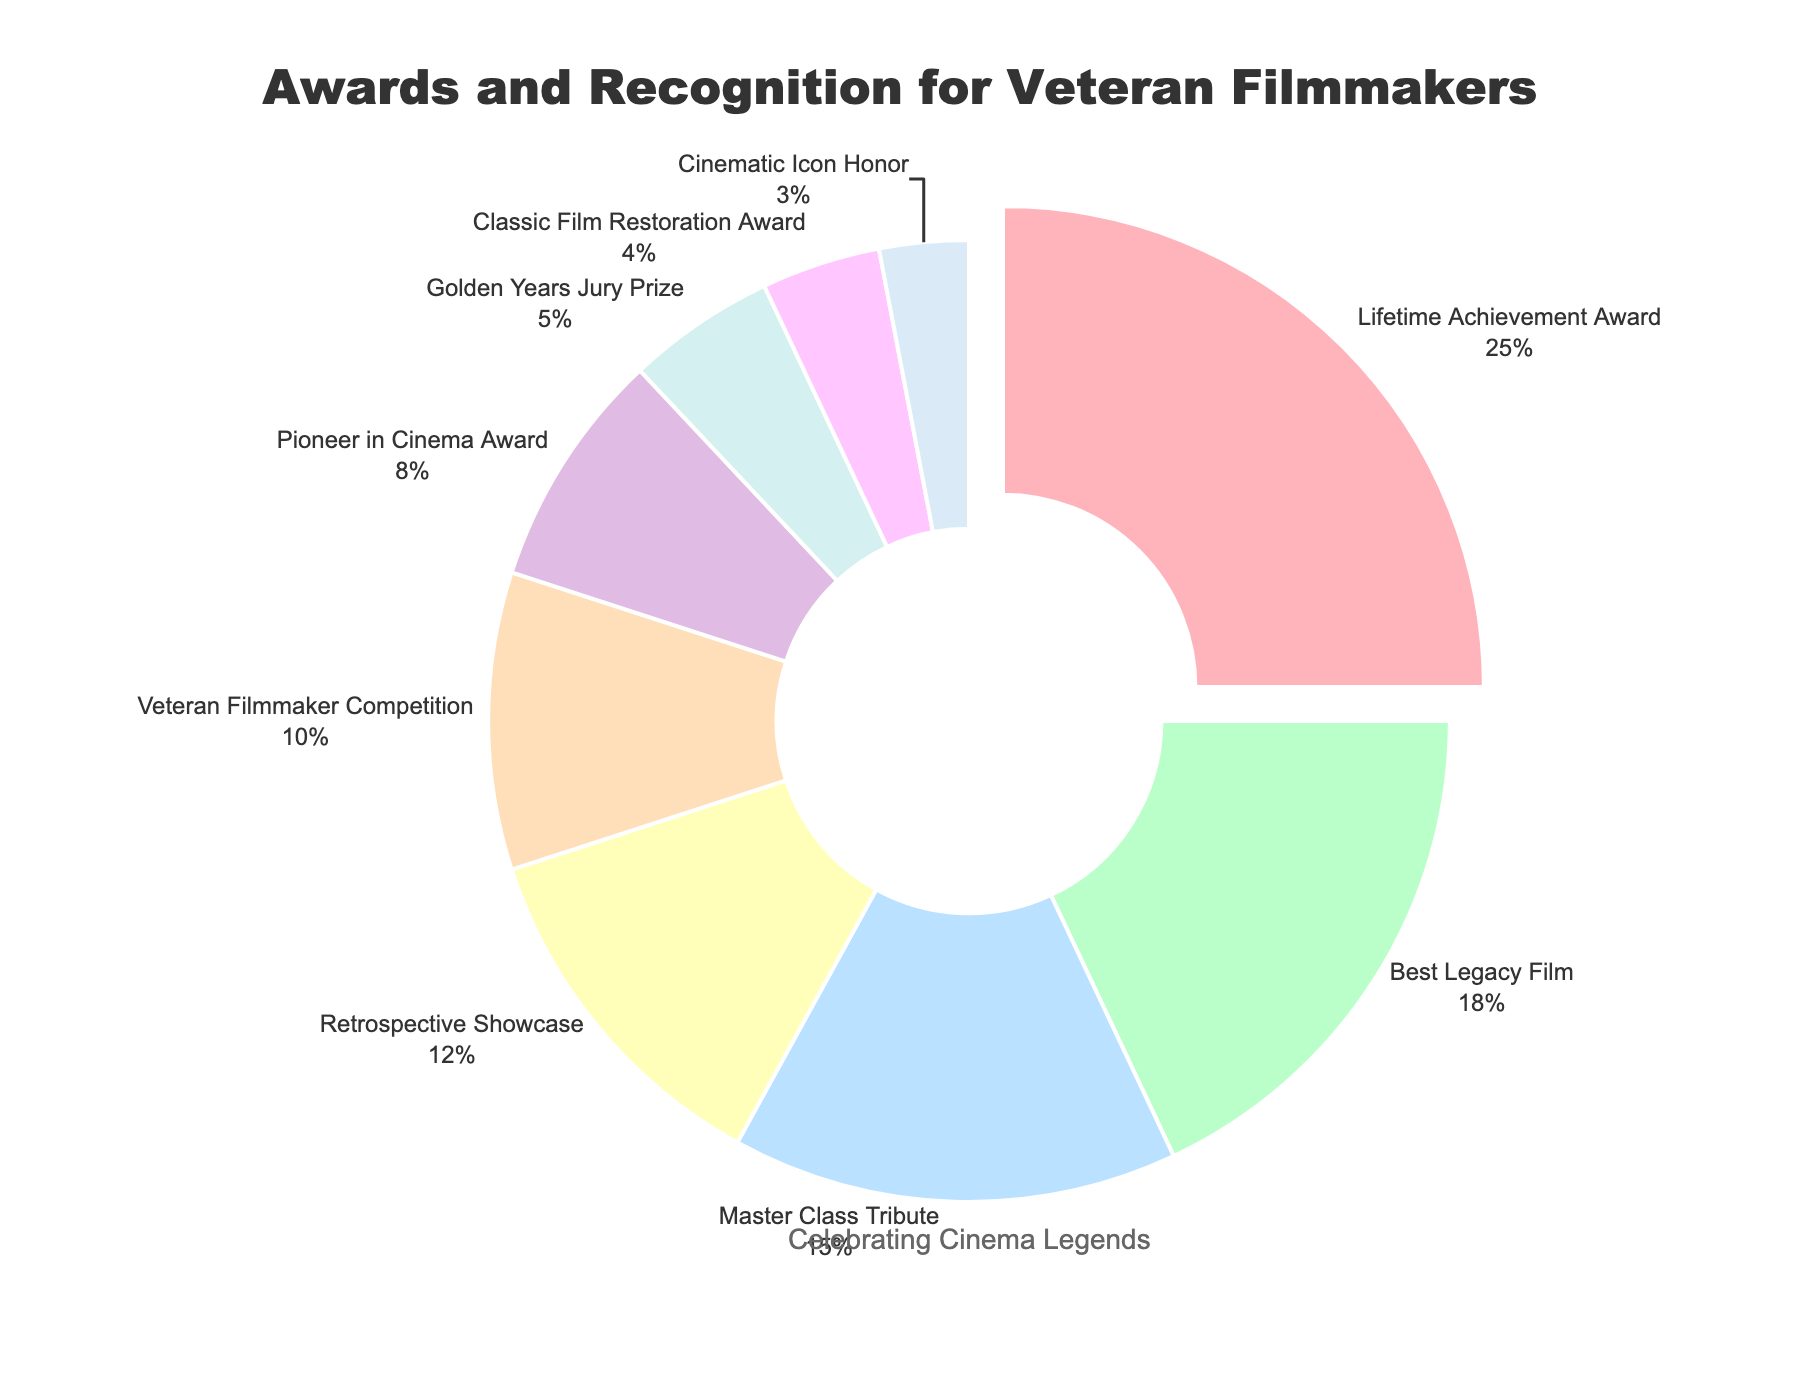What's the largest award category by percentage? The Lifetime Achievement Award occupies the largest portion of the pie chart, shown as the first slice which is also slightly pulled out. It is labeled with a percentage of 25%.
Answer: Lifetime Achievement Award How much more percentage does the Best Legacy Film category have compared to the Pioneer in Cinema Award category? To find the difference, subtract the Pioneer in Cinema Award percentage (8%) from the Best Legacy Film percentage (18%). The calculation is 18% - 8% = 10%.
Answer: 10% What is the combined percentage of the Retrospective Showcase and the Veteran Filmmaker Competition categories? Add the percentages of Retrospective Showcase (12%) and Veteran Filmmaker Competition (10%). The calculation is 12% + 10% = 22%.
Answer: 22% Which award category has the smallest representation in the pie chart? The smallest slice of the pie chart represents the Cinematic Icon Honor, which is labeled with a percentage of 3%.
Answer: Cinematic Icon Honor How does the percentage of the Master Class Tribute category compare to the Golden Years Jury Prize category? Compare the percentages: Master Class Tribute is 15% and Golden Years Jury Prize is 5%. Since 15% is greater than 5%, Master Class Tribute has a higher percentage.
Answer: Master Class Tribute has a higher percentage What proportion of the awards categories have a percentage higher than 15%? There are two categories with percentages higher than 15%: Lifetime Achievement Award (25%) and Best Legacy Film (18%). There are 9 categories in total, so the proportion is 2/9.
Answer: 2/9 What is the difference in percentage between the Retrospective Showcase and Classic Film Restoration Award categories? Subtract the Classic Film Restoration Award percentage (4%) from the Retrospective Showcase percentage (12%). The calculation is 12% - 4% = 8%.
Answer: 8% What is the total percentage of all categories listed in the pie chart? Adding up all the percentages given: 25% + 18% + 15% + 12% + 10% + 8% + 5% + 4% + 3% = 100%.
Answer: 100% Compare the combined percentage of awards for the top three largest categories with the combined percentage of the bottom three smallest categories. Which is greater? Sum the percentages of the top three categories: 25% (Lifetime Achievement Award) + 18% (Best Legacy Film) + 15% (Master Class Tribute) = 58%. Sum the percentages of the bottom three categories: 5% (Golden Years Jury Prize) + 4% (Classic Film Restoration Award) + 3% (Cinematic Icon Honor) = 12%. 58% is greater than 12%.
Answer: Top three categories' combined percentage is greater What percent of the pie chart represents categories receiving less than 10% each? Add the percentages of categories with less than 10% each: Veteran Filmmaker Competition (10%) + Pioneer in Cinema Award (8%) + Golden Years Jury Prize (5%) + Classic Film Restoration Award (4%) + Cinematic Icon Honor (3%). The calculation is 10% + 8% + 5% + 4% + 3% = 30%.
Answer: 30% 